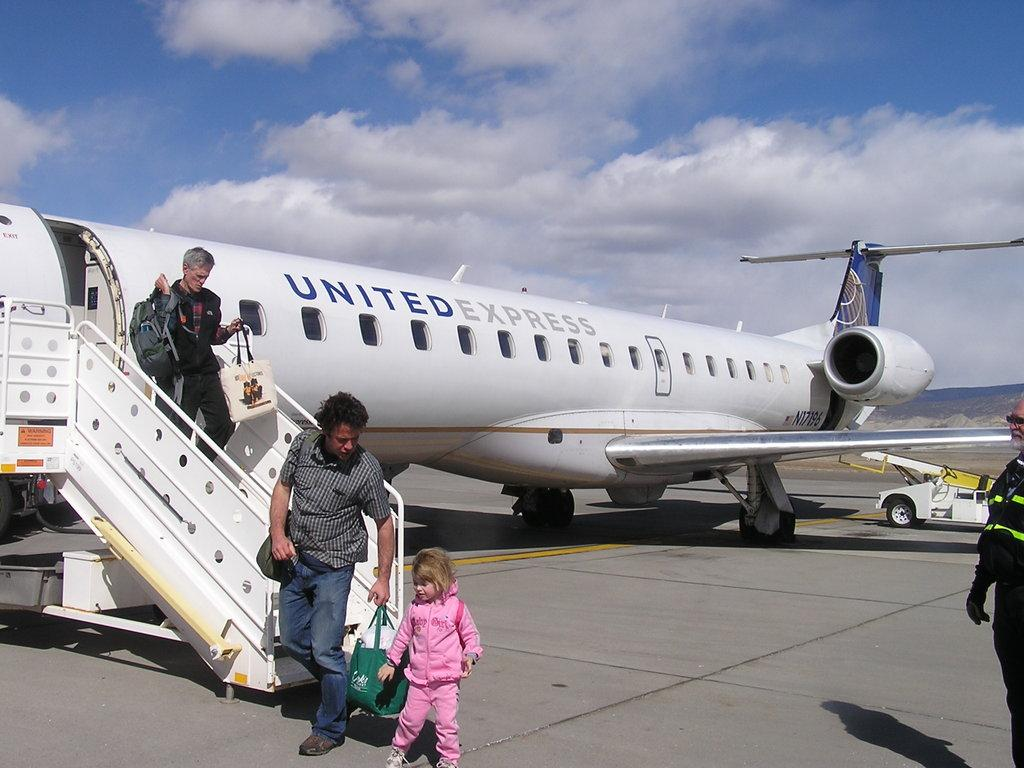<image>
Provide a brief description of the given image. Passengers are walking off a United Express jet. 